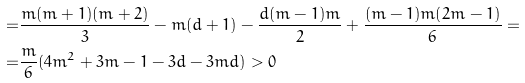Convert formula to latex. <formula><loc_0><loc_0><loc_500><loc_500>= & \frac { m ( m + 1 ) ( m + 2 ) } { 3 } - m ( d + 1 ) - \frac { d ( m - 1 ) m } { 2 } + \frac { ( m - 1 ) m ( 2 m - 1 ) } { 6 } = \\ = & \frac { m } { 6 } ( 4 m ^ { 2 } + 3 m - 1 - 3 d - 3 m d ) > 0</formula> 